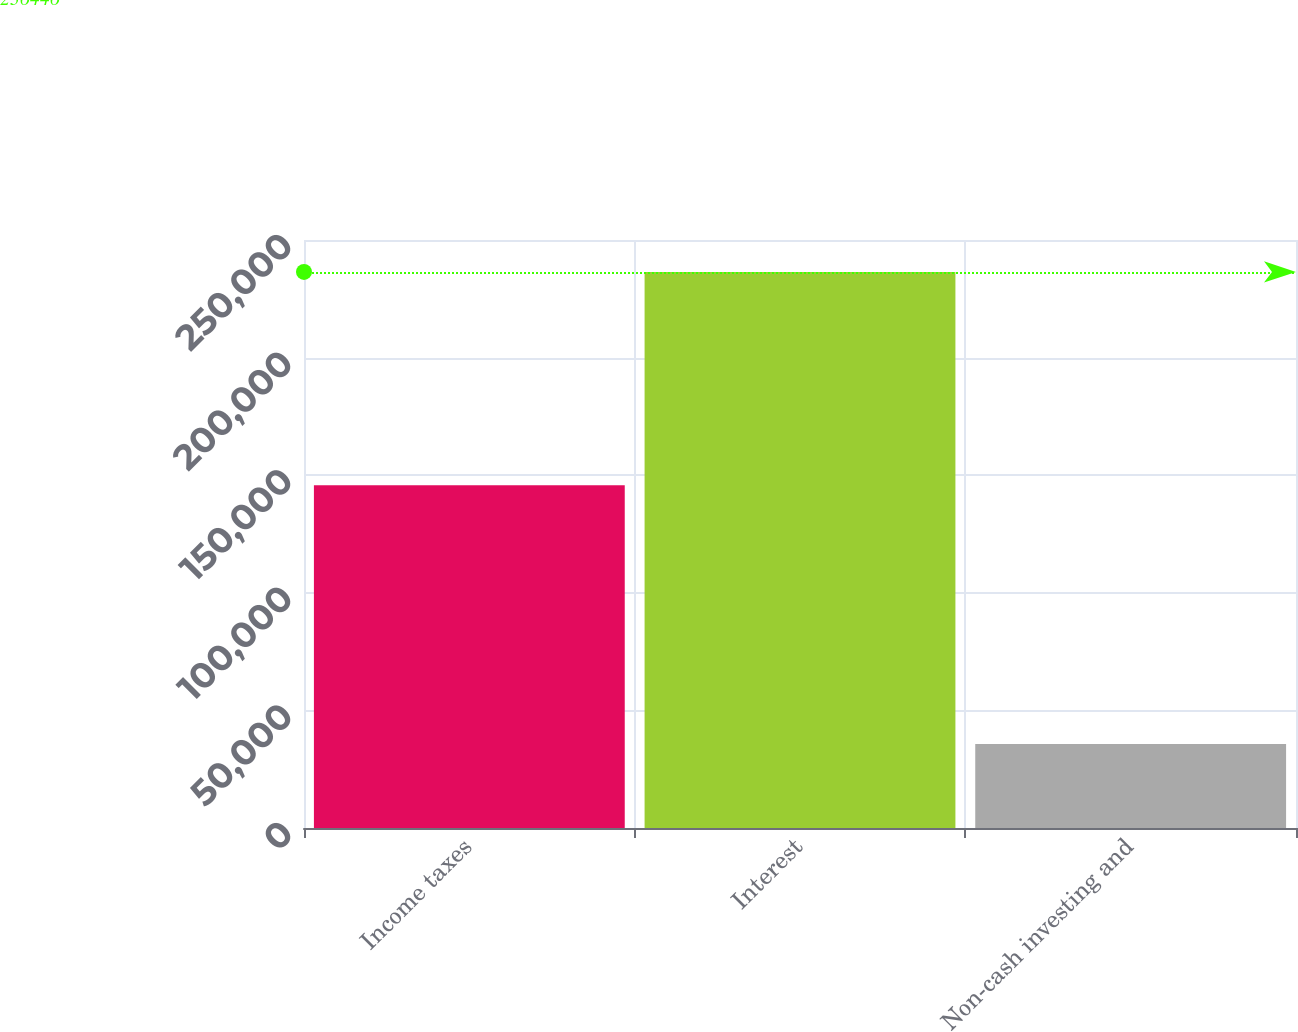Convert chart to OTSL. <chart><loc_0><loc_0><loc_500><loc_500><bar_chart><fcel>Income taxes<fcel>Interest<fcel>Non-cash investing and<nl><fcel>145687<fcel>236446<fcel>35764<nl></chart> 